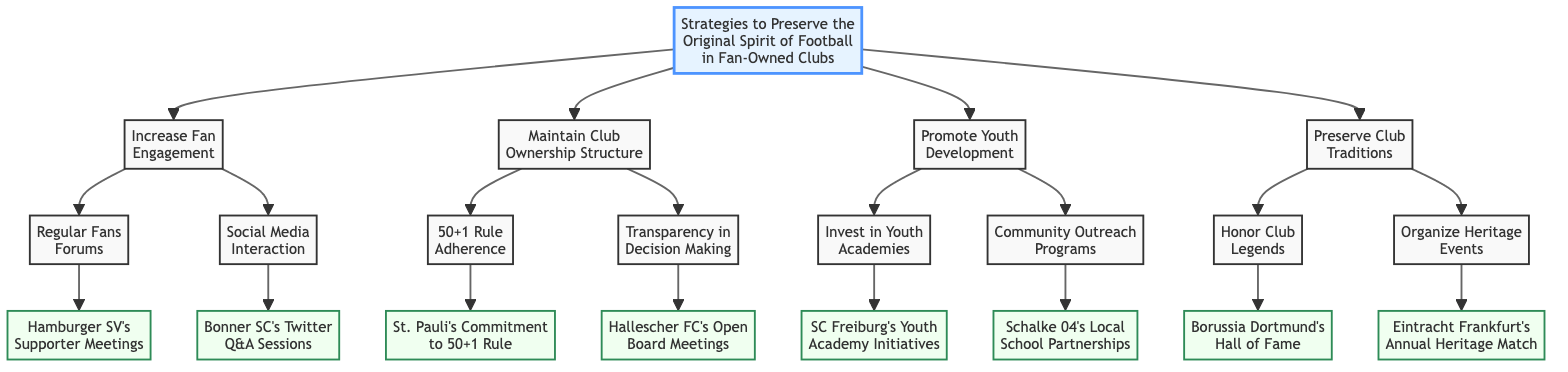What is the title of the decision tree? The title of the decision tree is "Strategies to Preserve the Original Spirit of Football in Fan-Owned Clubs," which is located at the top of the diagram.
Answer: Strategies to Preserve the Original Spirit of Football in Fan-Owned Clubs How many main strategies are proposed in the diagram? The diagram presents four main strategies that branch off from the root node: Increase Fan Engagement, Maintain Club Ownership Structure, Promote Youth Development, and Preserve Club Traditions.
Answer: 4 What club is associated with the Regular Fans Forums node? The node "Regular Fans Forums" has a child node that mentions "Hamburger SV's Supporter Meetings," indicating this club is directly associated with it.
Answer: Hamburger SV Which strategy includes the 50+1 Rule Adherence? The strategy that includes the 50+1 Rule Adherence is "Maintain Club Ownership Structure," which is one of the main strategies listed in the diagram.
Answer: Maintain Club Ownership Structure Which club shows a commitment to the 50+1 Rule? Under the 50+1 Rule Adherence node, it states "St. Pauli’s Commitment to 50+1 Rule," indicating that St. Pauli is the club that shows this commitment.
Answer: St. Pauli How many nodes are there under the "Promote Youth Development" strategy? The "Promote Youth Development" strategy contains two child nodes: "Invest in Youth Academies" and "Community Outreach Programs." Thus, there are two nodes under this strategy.
Answer: 2 What is the link between "Preserve Club Traditions" and "Honor Club Legends"? "Honor Club Legends" is a child node that branches out from the main strategy "Preserve Club Traditions," indicating that it is part of that broader strategy which focuses on preserving tradition.
Answer: Honor Club Legends Which specific event is associated with "Organize Heritage Events"? The node under "Organize Heritage Events" is specifically linked to "Eintracht Frankfurt's Annual Heritage Match," clearly identifying this event with the organization of heritage activities.
Answer: Eintracht Frankfurt's Annual Heritage Match What type of interaction is highlighted under "Increase Fan Engagement"? The diagram highlights regular fans forums and social media interaction, showing that both types of engagement are important for increasing fan engagement according to the strategies proposed.
Answer: Social Media Interaction 